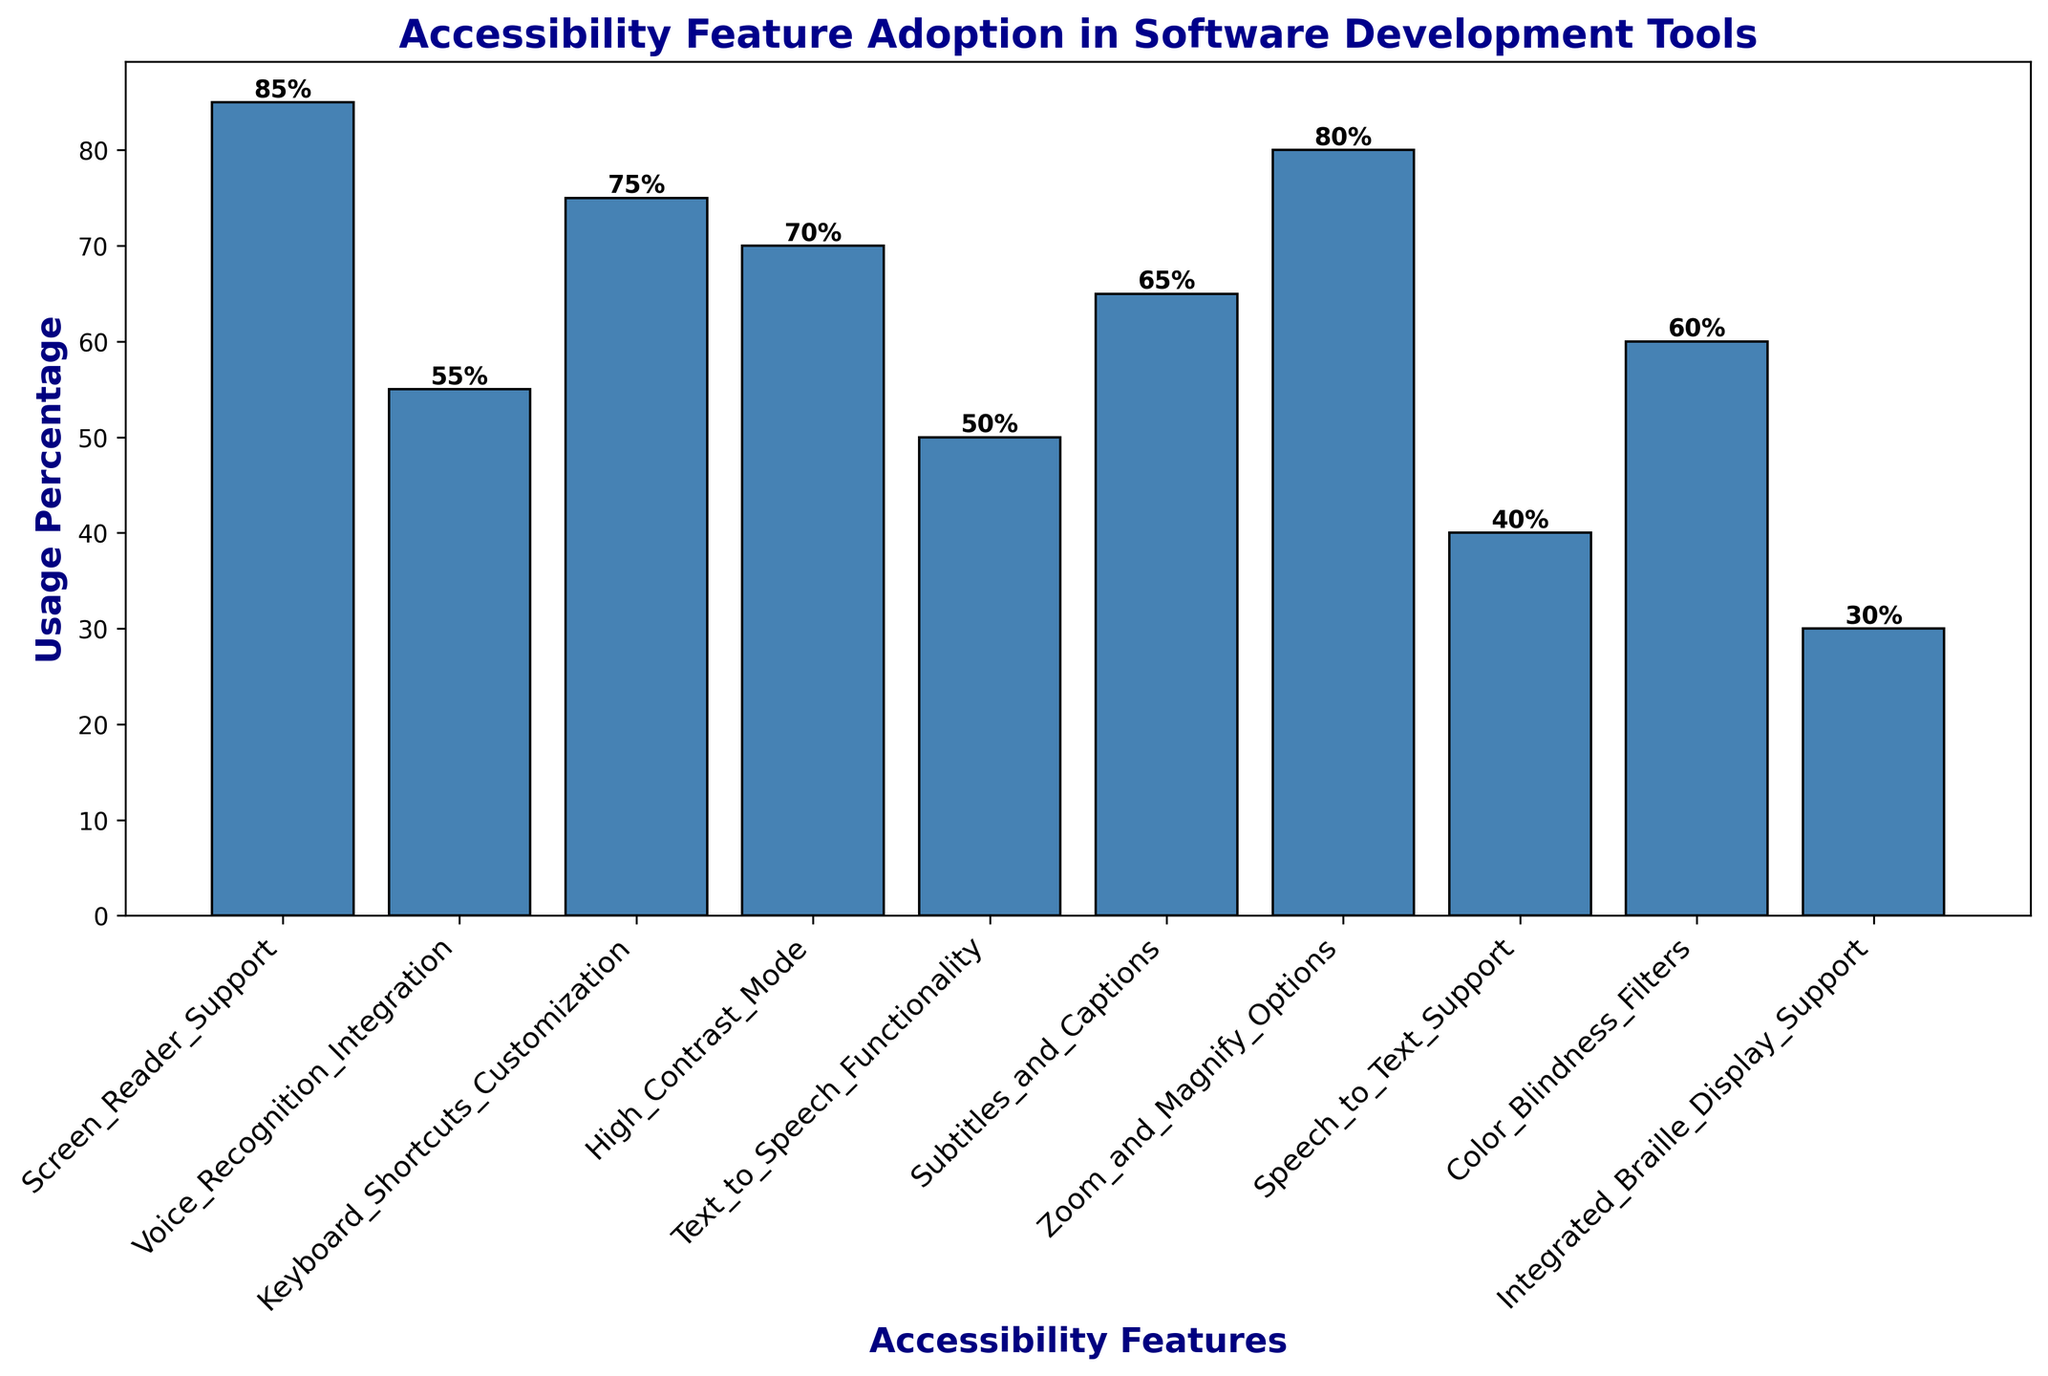What is the usage percentage of the feature with the highest adoption rate? The tallest bar in the plot represents the feature with the highest adoption rate. Looking at the plot, the highest bar corresponds to the "Screen Reader Support" feature. The percentage given on top of this bar is 85%.
Answer: 85% Which feature has the lowest usage percentage? The shortest bar in the plot represents the feature with the lowest usage rate. The shortest bar is for "Integrated Braille Display Support," with a percentage of 30%.
Answer: Integrated Braille Display Support How many features have a usage percentage greater than 70%? To determine this, count the number of bars that extend above the 70% mark on the y-axis. The bars for "Screen Reader Support," "Keyboard Shortcuts Customization," "Zoom and Magnify Options" exceed 70%. That is three features total.
Answer: 3 Which feature has 65% usage percentage? Look at the bar with the label showing 65% on top of it. This bar corresponds to the "Subtitles and Captions" feature.
Answer: Subtitles and Captions Which two features have the closest usage percentages, and what are those percentages? The closest bars in height appear to be "Voice Recognition Integration" and "Text to Speech Functionality." Checking the values, "Voice Recognition Integration" has 55%, and "Text to Speech Functionality" has 50%, making the difference 5%.
Answer: Voice Recognition Integration and Text to Speech Functionality, 55% and 50% What is the sum of the usage percentages of "High Contrast Mode" and "Color Blindness Filters"? Adding the percentages of "High Contrast Mode" (70%) and "Color Blindness Filters" (60%) gives a total of 70 + 60 = 130%.
Answer: 130% Are there more features with a usage percentage above or below 60%? Count the features with a usage percentage above 60% (Screen Reader Support, Zoom and Magnify Options, Keyboard Shortcuts Customization, High Contrast Mode, Subtitles and Captions) and those below 60% (Voice Recognition Integration, Text to Speech Functionality, Speech to Text Support, Color Blindness Filters, Integrated Braille Display Support). There are 5 features above 60% and 5 features below 60%. So, they are equal.
Answer: Equal Which features have a usage percentage of 50% or lower? Identify and list the bars at or below the 50% mark. "Text to Speech Functionality" (50%), "Speech to Text Support" (40%), and "Integrated Braille Display Support" (30%) fit this criterion.
Answer: Text to Speech Functionality, Speech to Text Support, Integrated Braille Display Support 